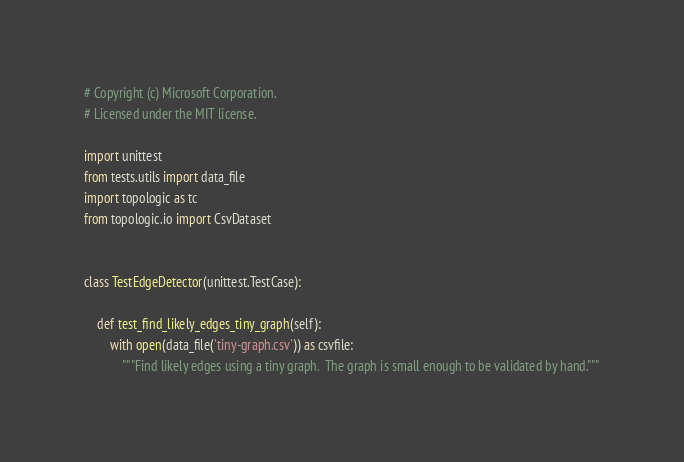<code> <loc_0><loc_0><loc_500><loc_500><_Python_># Copyright (c) Microsoft Corporation.
# Licensed under the MIT license.

import unittest
from tests.utils import data_file
import topologic as tc
from topologic.io import CsvDataset


class TestEdgeDetector(unittest.TestCase):

    def test_find_likely_edges_tiny_graph(self):
        with open(data_file('tiny-graph.csv')) as csvfile:
            """Find likely edges using a tiny graph.  The graph is small enough to be validated by hand."""</code> 